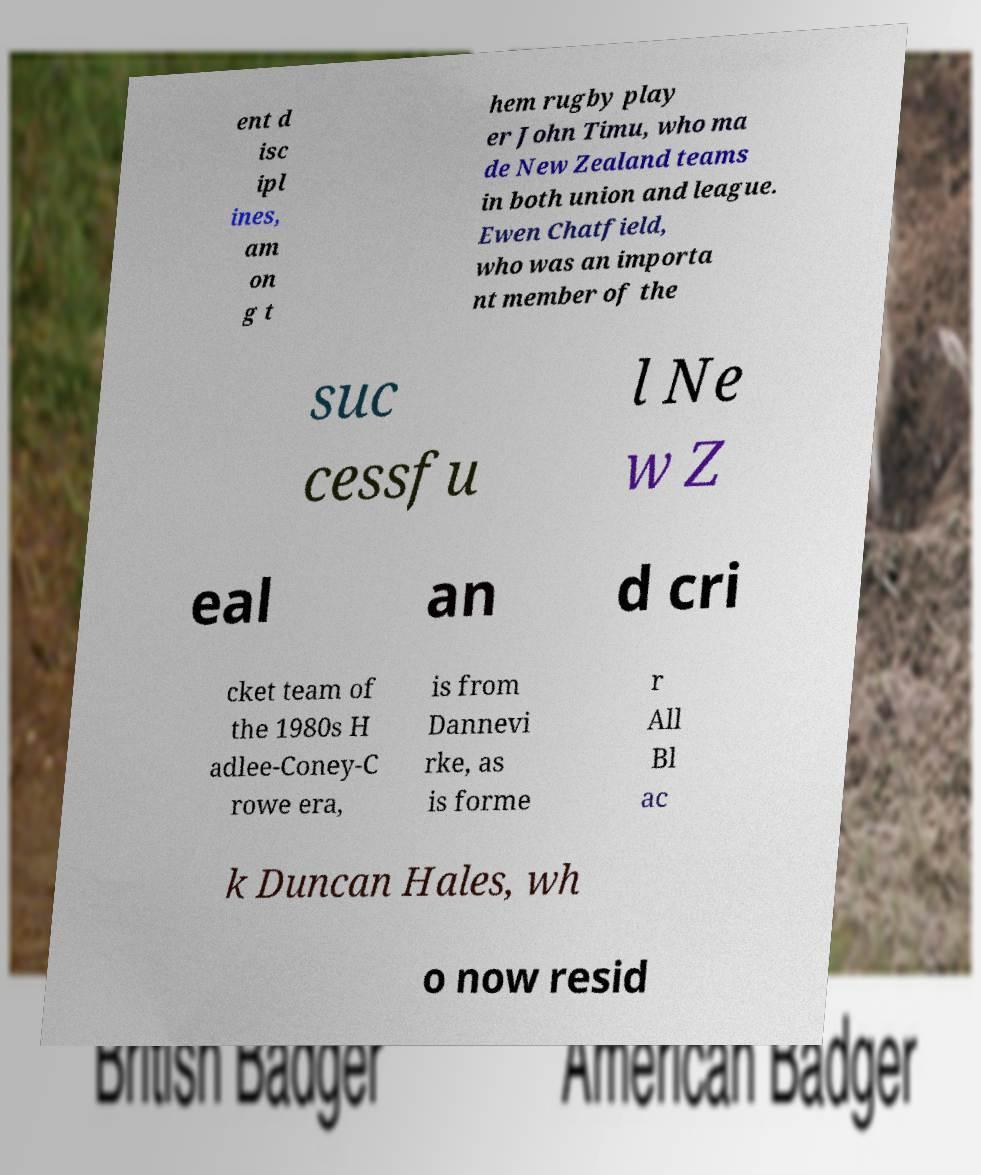Can you read and provide the text displayed in the image?This photo seems to have some interesting text. Can you extract and type it out for me? ent d isc ipl ines, am on g t hem rugby play er John Timu, who ma de New Zealand teams in both union and league. Ewen Chatfield, who was an importa nt member of the suc cessfu l Ne w Z eal an d cri cket team of the 1980s H adlee-Coney-C rowe era, is from Dannevi rke, as is forme r All Bl ac k Duncan Hales, wh o now resid 